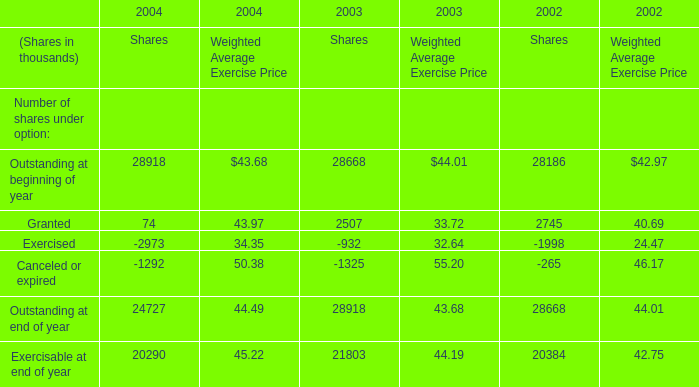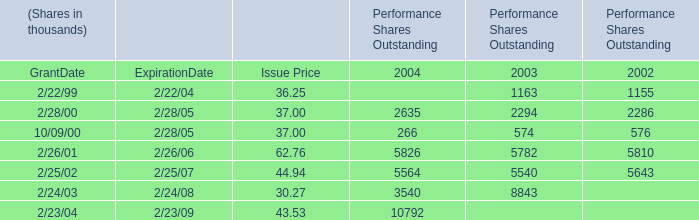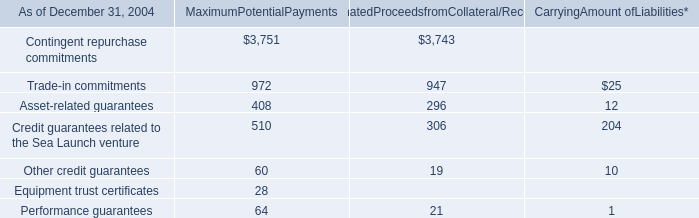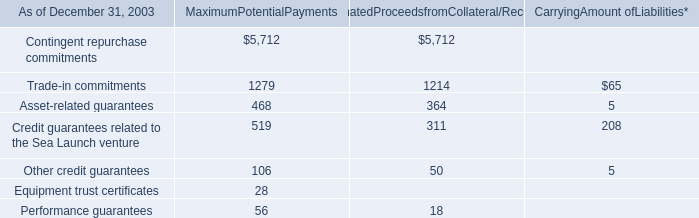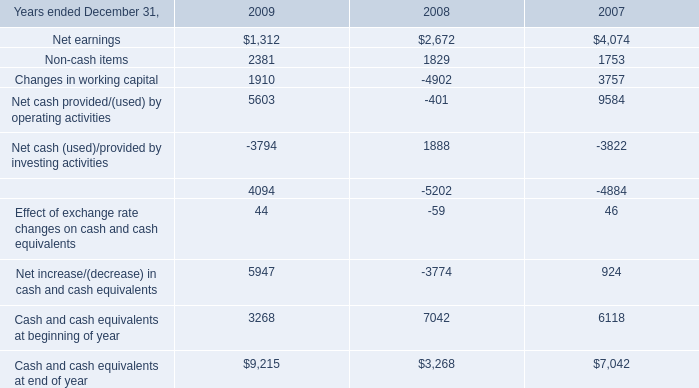In the year with lowest amount of Exercised, what's the increasing rate of Granted? 
Computations: (((2507 * 33.72) - (2745 * 40.69)) / (2745 * 40.69))
Answer: -0.24315. 